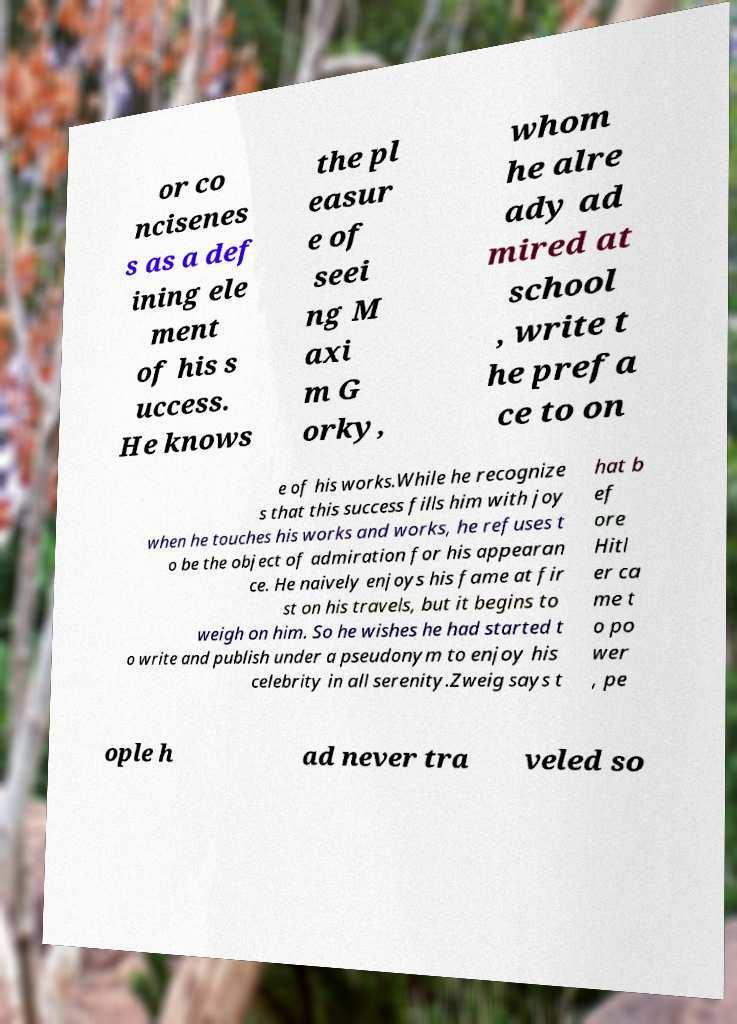For documentation purposes, I need the text within this image transcribed. Could you provide that? or co ncisenes s as a def ining ele ment of his s uccess. He knows the pl easur e of seei ng M axi m G orky, whom he alre ady ad mired at school , write t he prefa ce to on e of his works.While he recognize s that this success fills him with joy when he touches his works and works, he refuses t o be the object of admiration for his appearan ce. He naively enjoys his fame at fir st on his travels, but it begins to weigh on him. So he wishes he had started t o write and publish under a pseudonym to enjoy his celebrity in all serenity.Zweig says t hat b ef ore Hitl er ca me t o po wer , pe ople h ad never tra veled so 